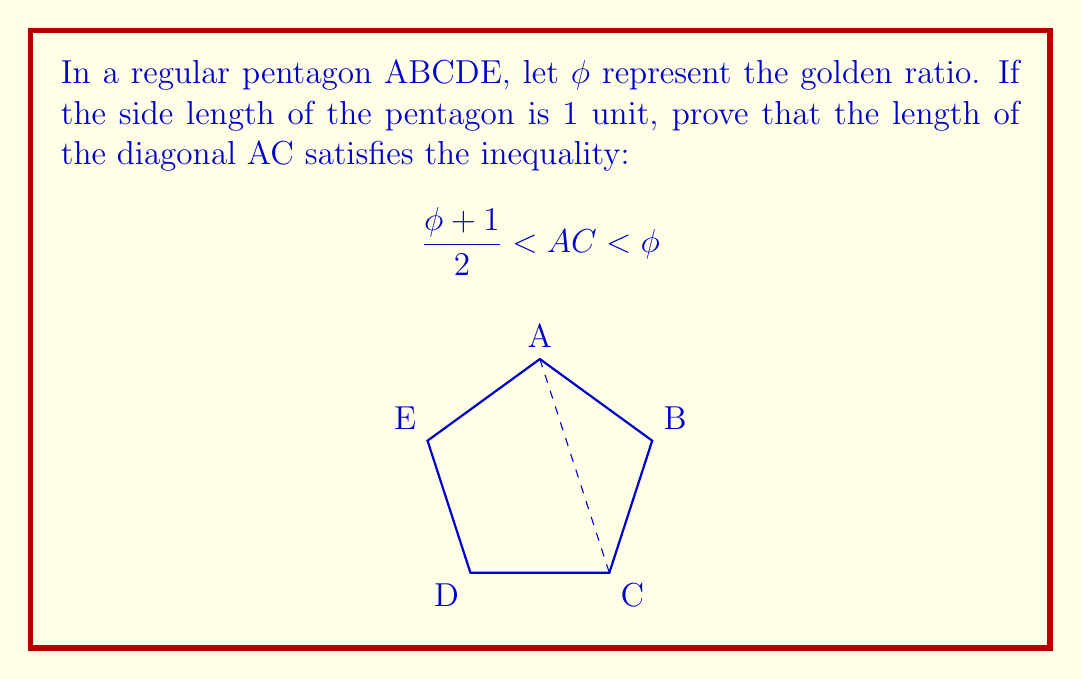Provide a solution to this math problem. Let's approach this step-by-step:

1) First, recall that the golden ratio $\phi$ is defined as:

   $$\phi = \frac{1 + \sqrt{5}}{2} \approx 1.618$$

2) In a regular pentagon, the ratio of a diagonal to a side is equal to $\phi$. However, this is true for the longer diagonal (e.g., AC in the diagram). The shorter diagonal (e.g., BD) has a different ratio.

3) The length of the shorter diagonal (let's call it $d$) in a unit pentagon satisfies:

   $$d^2 = \phi$$

4) This is because the shorter diagonal divides the longer diagonal into two segments, with the ratio of the longer segment to the shorter segment being $\phi$.

5) Now, let's consider the triangle ABC. We know AB = 1 (given), and BC = 1 (as it's a side of the pentagon). We need to find AC.

6) Using the cosine law in triangle ABC:

   $$AC^2 = 1^2 + 1^2 - 2(1)(1)\cos 108°$$

7) We know that in a regular pentagon, each internal angle is 108°.

8) Simplifying:

   $$AC^2 = 2 - 2\cos 108°$$

9) Now, $\cos 108° = -\frac{\phi}{2}$. Substituting this:

   $$AC^2 = 2 + \phi = \frac{3 + \sqrt{5}}{2}$$

10) Taking the square root:

    $$AC = \sqrt{\frac{3 + \sqrt{5}}{2}}$$

11) This value lies between $\frac{\phi + 1}{2}$ and $\phi$:

    $$\frac{\phi + 1}{2} = \frac{1 + \sqrt{5} + 2}{4} = \frac{3 + \sqrt{5}}{4} \approx 1.309$$
    
    $$\phi = \frac{1 + \sqrt{5}}{2} \approx 1.618$$

    $$\sqrt{\frac{3 + \sqrt{5}}{2}} \approx 1.618$$

Therefore, we have proven that $\frac{\phi + 1}{2} < AC < \phi$.
Answer: The inequality $\frac{\phi + 1}{2} < AC < \phi$ is true, where AC = $\sqrt{\frac{3 + \sqrt{5}}{2}}$. 